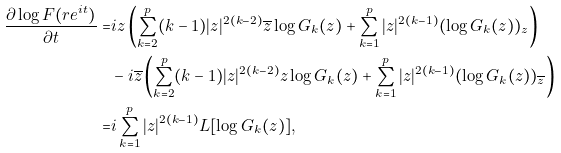Convert formula to latex. <formula><loc_0><loc_0><loc_500><loc_500>\frac { \partial \log F ( r e ^ { i t } ) } { \partial t } = & i z \left ( \sum _ { k = 2 } ^ { p } ( k - 1 ) | z | ^ { 2 ( k - 2 ) } \overline { z } \log G _ { k } ( z ) + \sum _ { k = 1 } ^ { p } | z | ^ { 2 ( k - 1 ) } ( \log G _ { k } ( z ) ) _ { z } \right ) \\ & - i \overline { z } \left ( \sum _ { k = 2 } ^ { p } ( k - 1 ) | z | ^ { 2 ( k - 2 ) } z \log G _ { k } ( z ) + \sum _ { k = 1 } ^ { p } | z | ^ { 2 ( k - 1 ) } ( \log G _ { k } ( z ) ) _ { \overline { z } } \right ) \\ = & i \sum _ { k = 1 } ^ { p } | z | ^ { 2 ( k - 1 ) } L [ \log G _ { k } ( z ) ] ,</formula> 